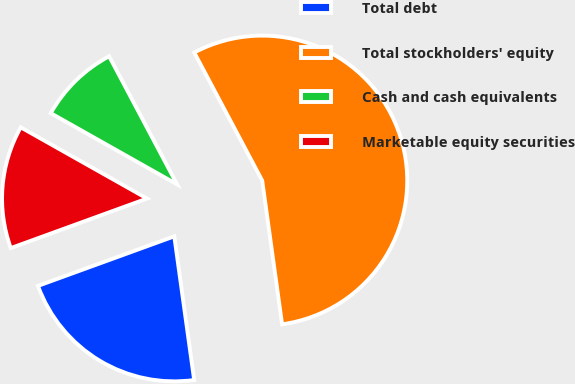Convert chart to OTSL. <chart><loc_0><loc_0><loc_500><loc_500><pie_chart><fcel>Total debt<fcel>Total stockholders' equity<fcel>Cash and cash equivalents<fcel>Marketable equity securities<nl><fcel>21.64%<fcel>55.58%<fcel>9.07%<fcel>13.72%<nl></chart> 